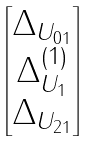<formula> <loc_0><loc_0><loc_500><loc_500>\begin{bmatrix} \Delta _ { U _ { 0 1 } } \\ \Delta ^ { ( 1 ) } _ { U _ { 1 } } \\ \Delta _ { U _ { 2 1 } } \end{bmatrix}</formula> 